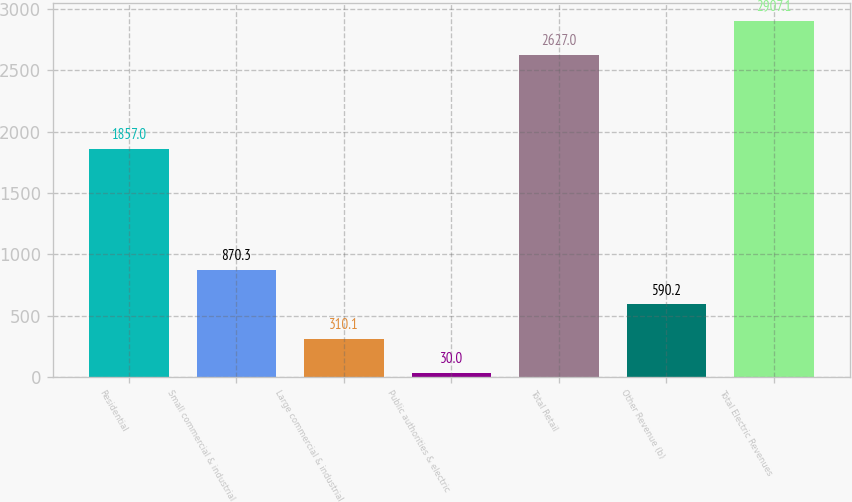<chart> <loc_0><loc_0><loc_500><loc_500><bar_chart><fcel>Residential<fcel>Small commercial & industrial<fcel>Large commercial & industrial<fcel>Public authorities & electric<fcel>Total Retail<fcel>Other Revenue (b)<fcel>Total Electric Revenues<nl><fcel>1857<fcel>870.3<fcel>310.1<fcel>30<fcel>2627<fcel>590.2<fcel>2907.1<nl></chart> 